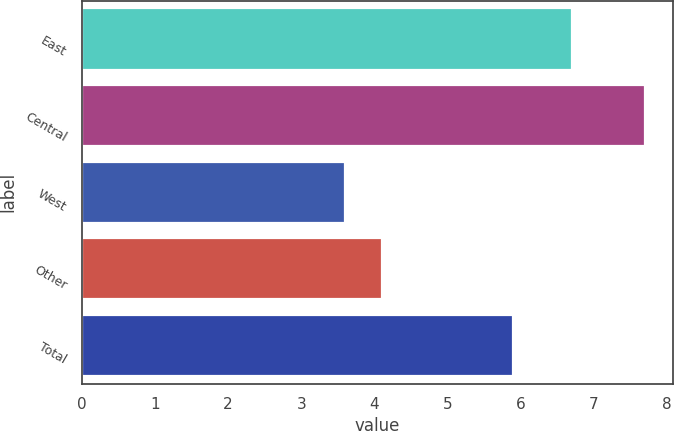<chart> <loc_0><loc_0><loc_500><loc_500><bar_chart><fcel>East<fcel>Central<fcel>West<fcel>Other<fcel>Total<nl><fcel>6.7<fcel>7.7<fcel>3.6<fcel>4.1<fcel>5.9<nl></chart> 